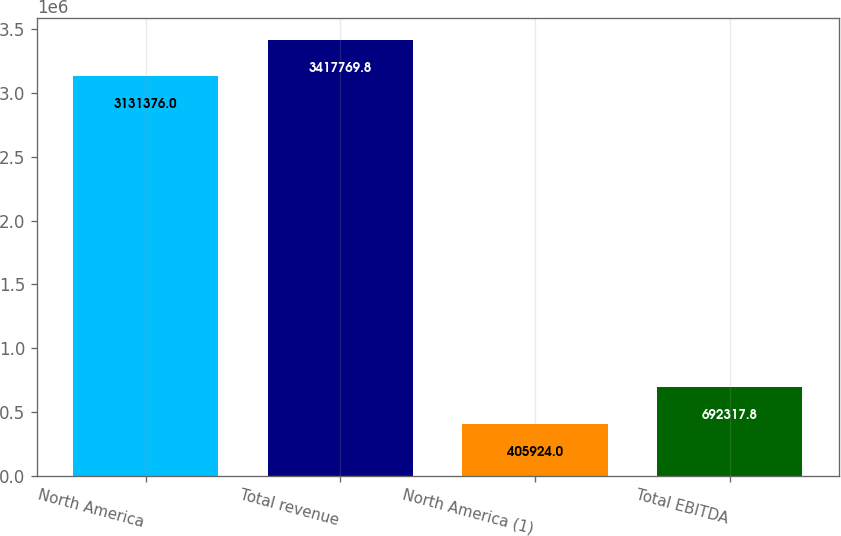Convert chart. <chart><loc_0><loc_0><loc_500><loc_500><bar_chart><fcel>North America<fcel>Total revenue<fcel>North America (1)<fcel>Total EBITDA<nl><fcel>3.13138e+06<fcel>3.41777e+06<fcel>405924<fcel>692318<nl></chart> 